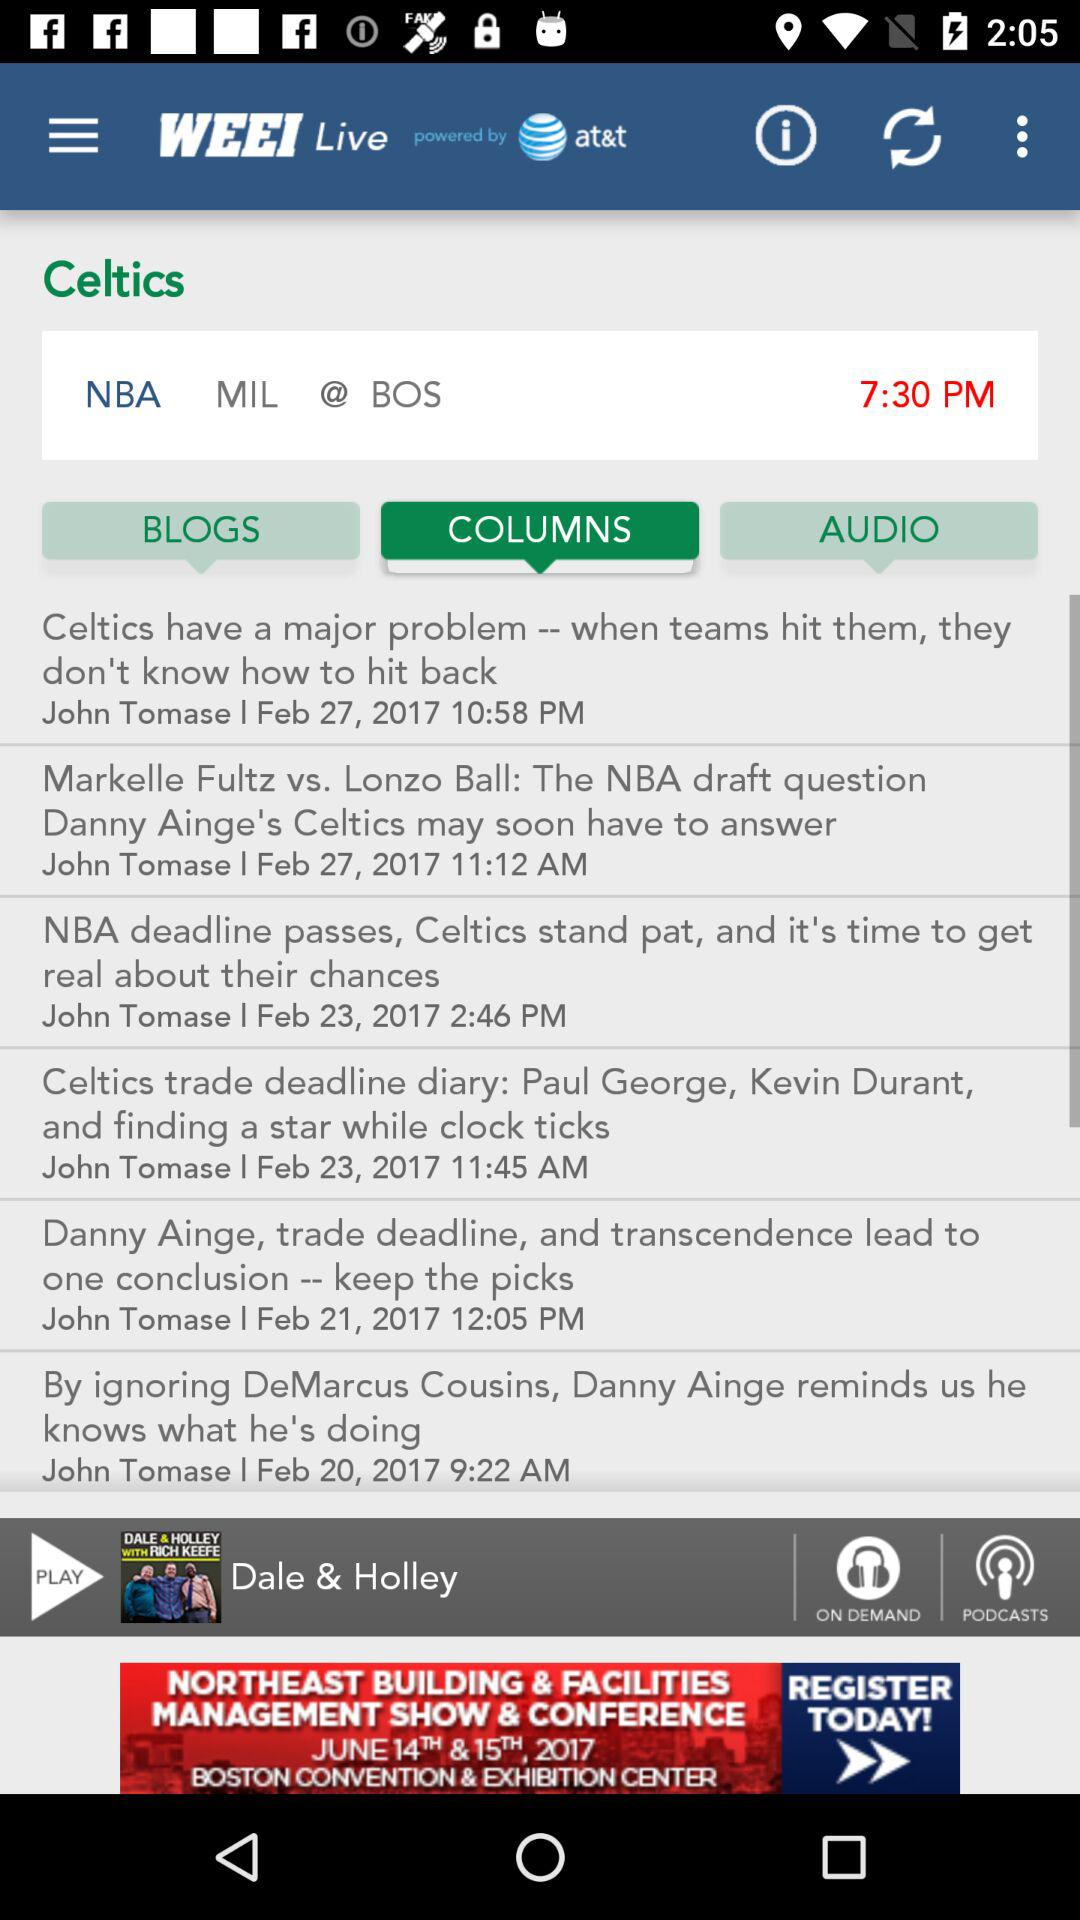What is the given time? The given time is 7:30 PM. 